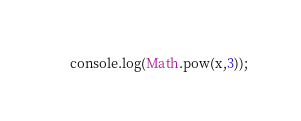Convert code to text. <code><loc_0><loc_0><loc_500><loc_500><_JavaScript_>console.log(Math.pow(x,3));
</code> 